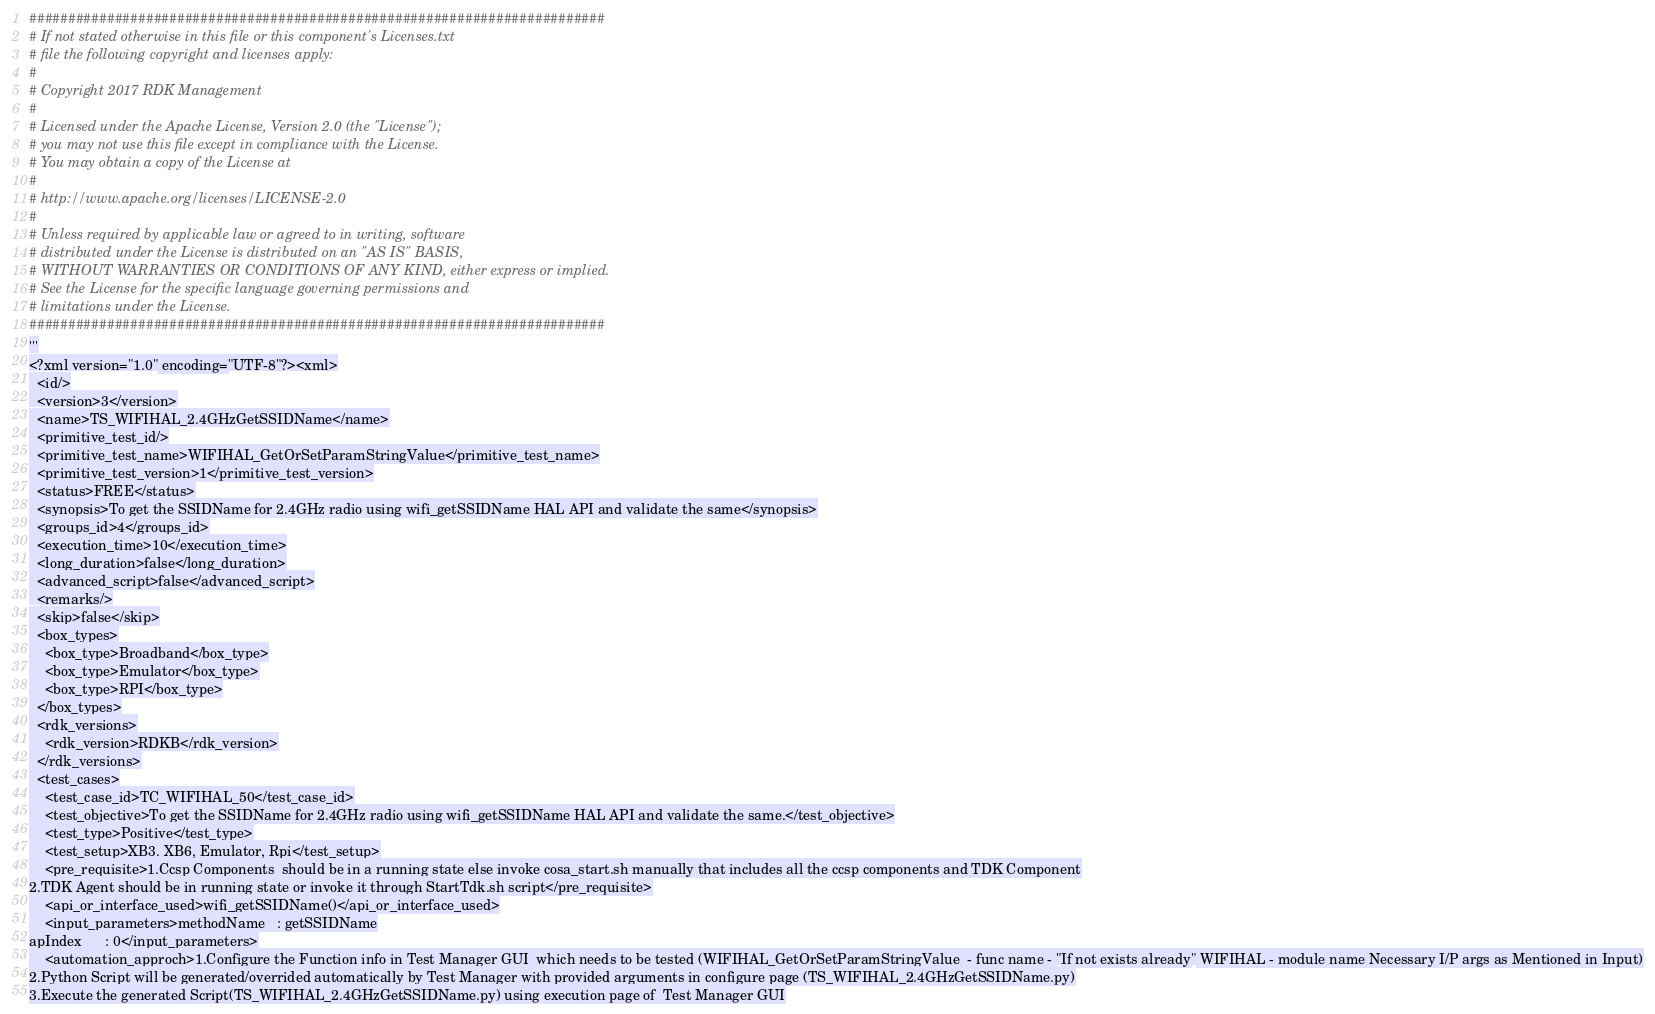Convert code to text. <code><loc_0><loc_0><loc_500><loc_500><_Python_>##########################################################################
# If not stated otherwise in this file or this component's Licenses.txt
# file the following copyright and licenses apply:
#
# Copyright 2017 RDK Management
#
# Licensed under the Apache License, Version 2.0 (the "License");
# you may not use this file except in compliance with the License.
# You may obtain a copy of the License at
#
# http://www.apache.org/licenses/LICENSE-2.0
#
# Unless required by applicable law or agreed to in writing, software
# distributed under the License is distributed on an "AS IS" BASIS,
# WITHOUT WARRANTIES OR CONDITIONS OF ANY KIND, either express or implied.
# See the License for the specific language governing permissions and
# limitations under the License.
##########################################################################
'''
<?xml version="1.0" encoding="UTF-8"?><xml>
  <id/>
  <version>3</version>
  <name>TS_WIFIHAL_2.4GHzGetSSIDName</name>
  <primitive_test_id/>
  <primitive_test_name>WIFIHAL_GetOrSetParamStringValue</primitive_test_name>
  <primitive_test_version>1</primitive_test_version>
  <status>FREE</status>
  <synopsis>To get the SSIDName for 2.4GHz radio using wifi_getSSIDName HAL API and validate the same</synopsis>
  <groups_id>4</groups_id>
  <execution_time>10</execution_time>
  <long_duration>false</long_duration>
  <advanced_script>false</advanced_script>
  <remarks/>
  <skip>false</skip>
  <box_types>
    <box_type>Broadband</box_type>
    <box_type>Emulator</box_type>
    <box_type>RPI</box_type>
  </box_types>
  <rdk_versions>
    <rdk_version>RDKB</rdk_version>
  </rdk_versions>
  <test_cases>
    <test_case_id>TC_WIFIHAL_50</test_case_id>
    <test_objective>To get the SSIDName for 2.4GHz radio using wifi_getSSIDName HAL API and validate the same.</test_objective>
    <test_type>Positive</test_type>
    <test_setup>XB3. XB6, Emulator, Rpi</test_setup>
    <pre_requisite>1.Ccsp Components  should be in a running state else invoke cosa_start.sh manually that includes all the ccsp components and TDK Component
2.TDK Agent should be in running state or invoke it through StartTdk.sh script</pre_requisite>
    <api_or_interface_used>wifi_getSSIDName()</api_or_interface_used>
    <input_parameters>methodName   : getSSIDName
apIndex      : 0</input_parameters>
    <automation_approch>1.Configure the Function info in Test Manager GUI  which needs to be tested (WIFIHAL_GetOrSetParamStringValue  - func name - "If not exists already" WIFIHAL - module name Necessary I/P args as Mentioned in Input)
2.Python Script will be generated/overrided automatically by Test Manager with provided arguments in configure page (TS_WIFIHAL_2.4GHzGetSSIDName.py)
3.Execute the generated Script(TS_WIFIHAL_2.4GHzGetSSIDName.py) using execution page of  Test Manager GUI</code> 